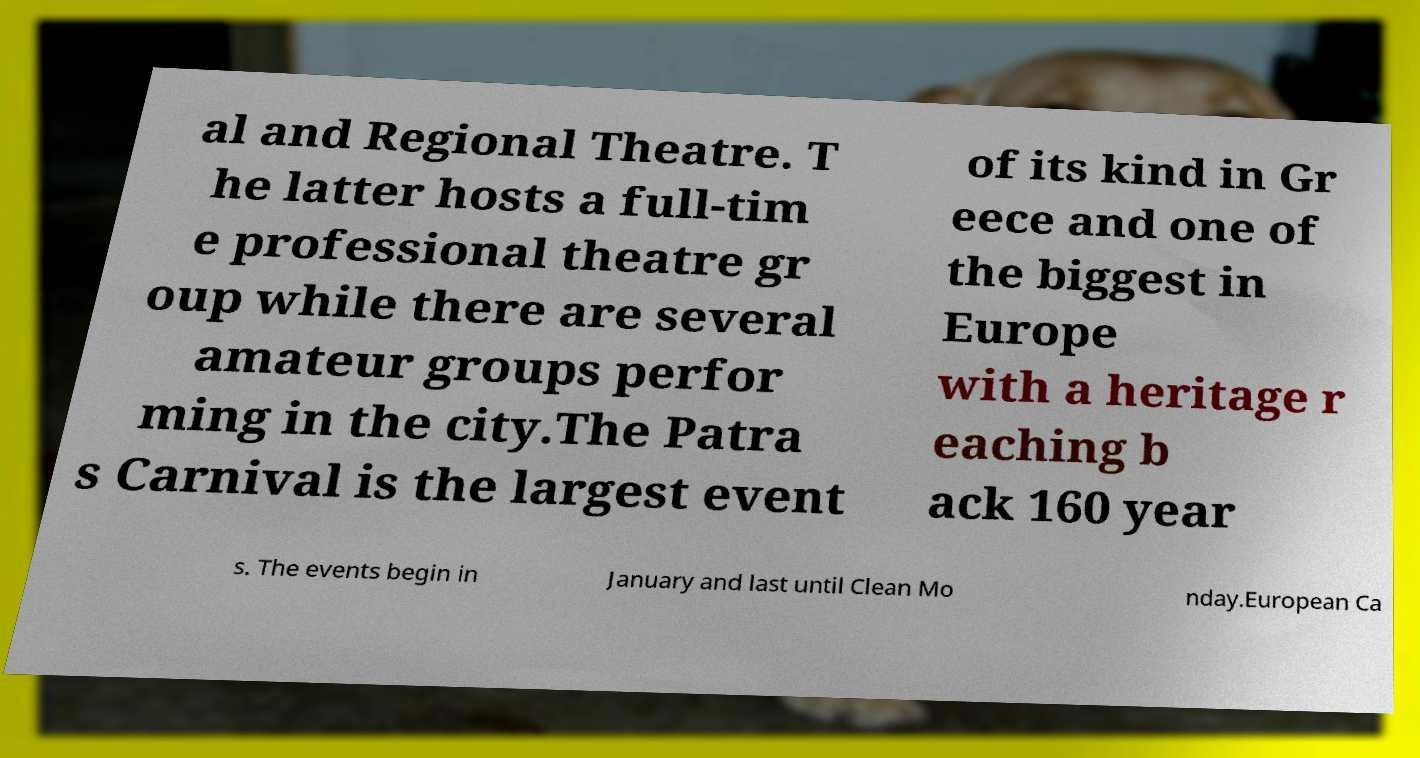Could you extract and type out the text from this image? al and Regional Theatre. T he latter hosts a full-tim e professional theatre gr oup while there are several amateur groups perfor ming in the city.The Patra s Carnival is the largest event of its kind in Gr eece and one of the biggest in Europe with a heritage r eaching b ack 160 year s. The events begin in January and last until Clean Mo nday.European Ca 